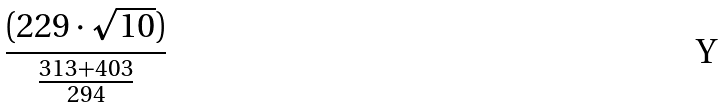<formula> <loc_0><loc_0><loc_500><loc_500>\frac { ( 2 2 9 \cdot \sqrt { 1 0 } ) } { \frac { 3 1 3 + 4 0 3 } { 2 9 4 } }</formula> 